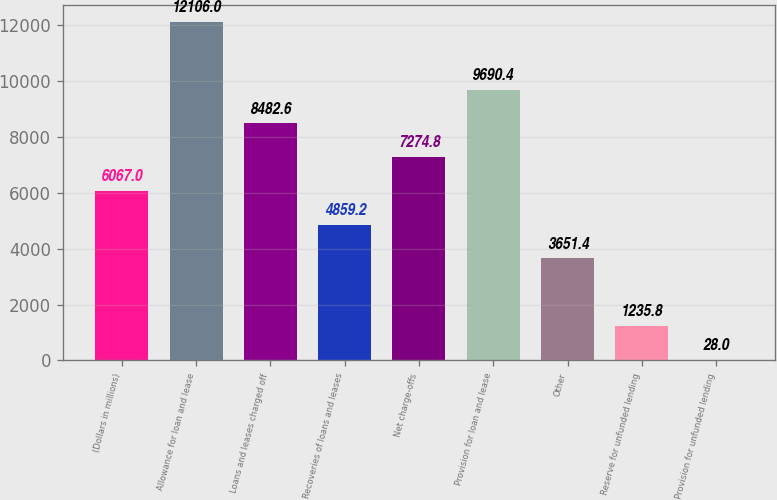<chart> <loc_0><loc_0><loc_500><loc_500><bar_chart><fcel>(Dollars in millions)<fcel>Allowance for loan and lease<fcel>Loans and leases charged off<fcel>Recoveries of loans and leases<fcel>Net charge-offs<fcel>Provision for loan and lease<fcel>Other<fcel>Reserve for unfunded lending<fcel>Provision for unfunded lending<nl><fcel>6067<fcel>12106<fcel>8482.6<fcel>4859.2<fcel>7274.8<fcel>9690.4<fcel>3651.4<fcel>1235.8<fcel>28<nl></chart> 